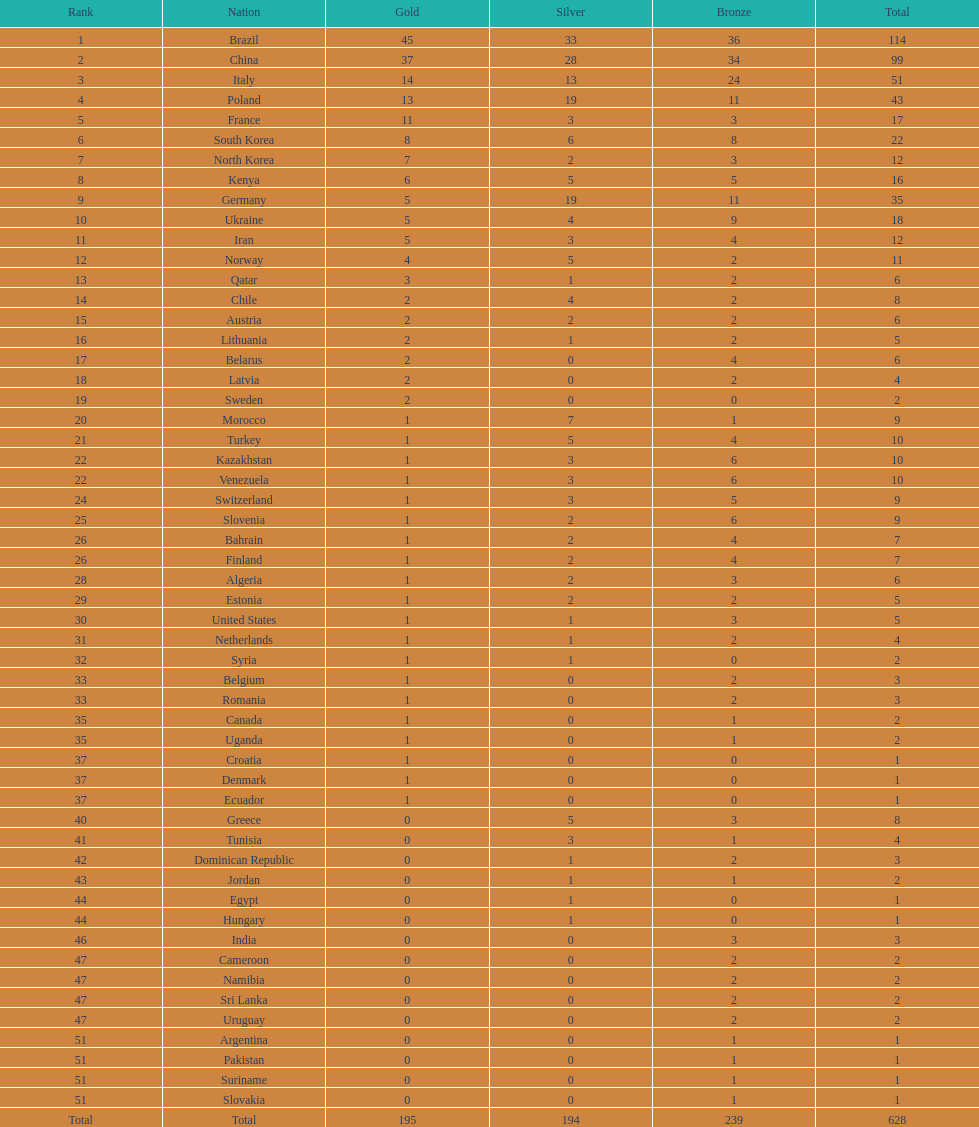Did either italy or norway achieve a total of 51 medals? Italy. 